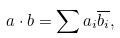Convert formula to latex. <formula><loc_0><loc_0><loc_500><loc_500>a \cdot b = \sum { a _ { i } { \overline { { b _ { i } } } } } ,</formula> 